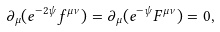Convert formula to latex. <formula><loc_0><loc_0><loc_500><loc_500>\partial _ { \mu } ( e ^ { - 2 \psi } f ^ { \mu \nu } ) = \partial _ { \mu } ( e ^ { - \psi } F ^ { \mu \nu } ) = 0 ,</formula> 